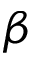Convert formula to latex. <formula><loc_0><loc_0><loc_500><loc_500>\beta</formula> 